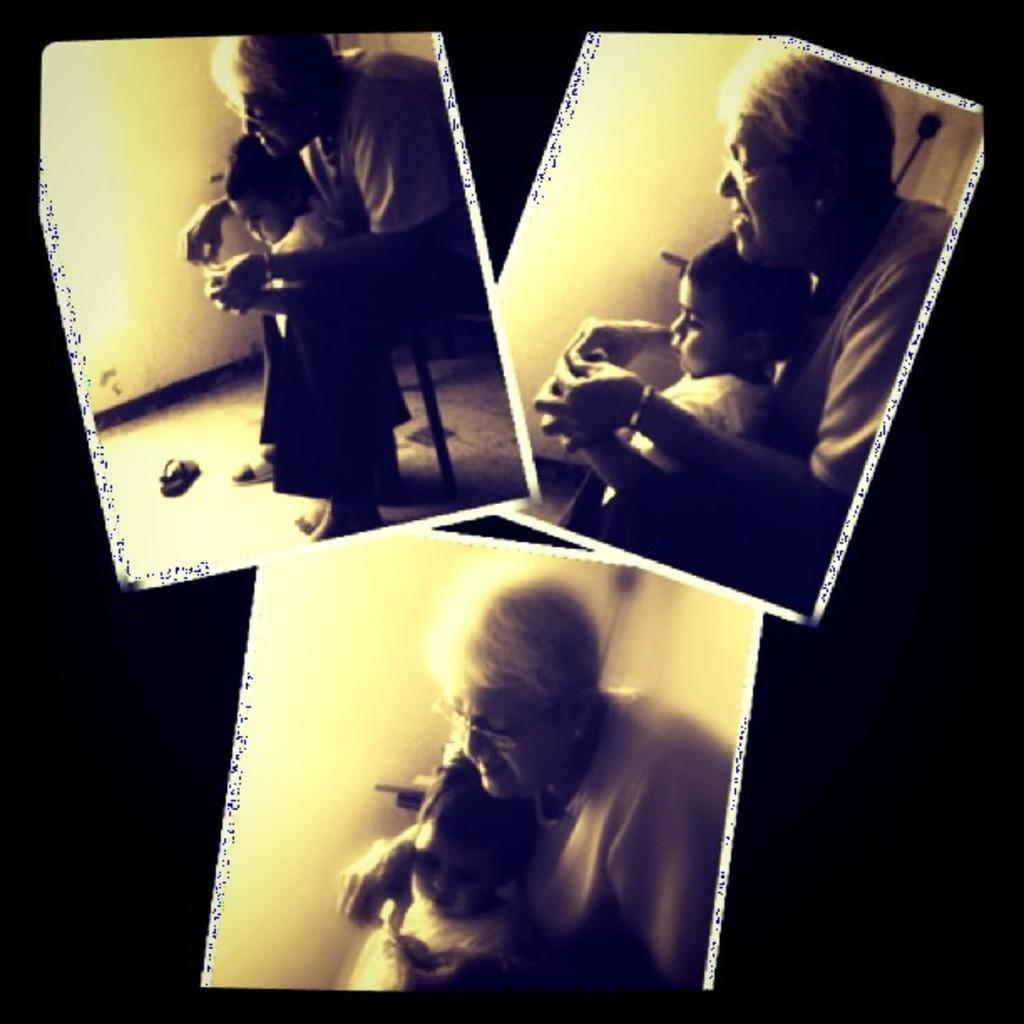What type of artwork is the image? The image is a collage. Who are the main subjects in the collage? There is a grandmother and a girl in the collage. What are the grandmother and girl doing in the collage? The grandmother and girl are playing with images in the collage. What type of bird is sitting on the girl's hair in the image? There is no bird present in the image, and the girl's hair is not mentioned in the provided facts. 